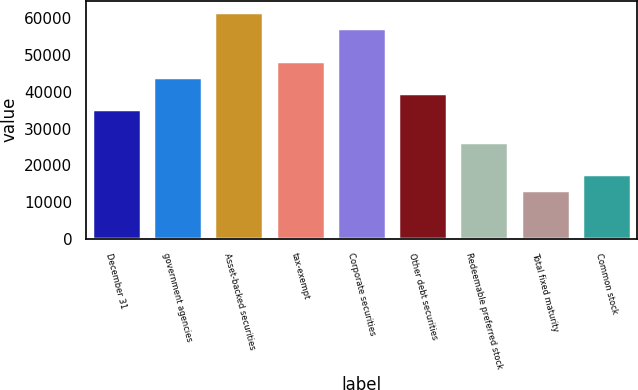Convert chart. <chart><loc_0><loc_0><loc_500><loc_500><bar_chart><fcel>December 31<fcel>government agencies<fcel>Asset-backed securities<fcel>tax-exempt<fcel>Corporate securities<fcel>Other debt securities<fcel>Redeemable preferred stock<fcel>Total fixed maturity<fcel>Common stock<nl><fcel>35282<fcel>44096<fcel>61724<fcel>48503<fcel>57317<fcel>39689<fcel>26468<fcel>13247<fcel>17654<nl></chart> 